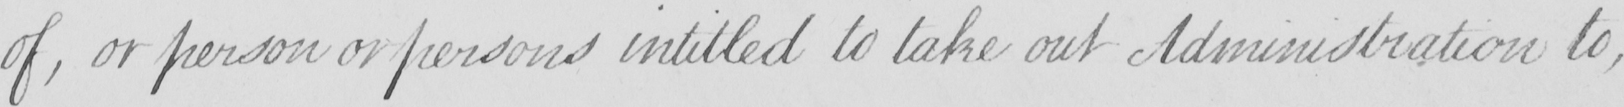Please provide the text content of this handwritten line. of , or person or persons intitled to take out Administration to , 